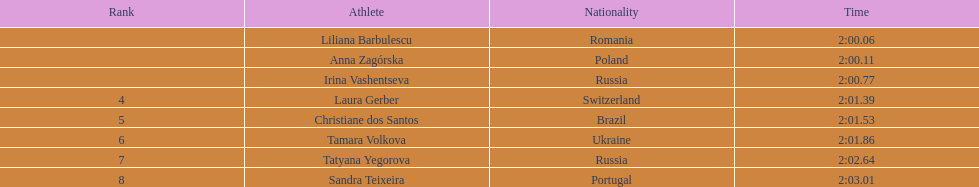Who were all of the athletes? Liliana Barbulescu, Anna Zagórska, Irina Vashentseva, Laura Gerber, Christiane dos Santos, Tamara Volkova, Tatyana Yegorova, Sandra Teixeira. What were their finishing times? 2:00.06, 2:00.11, 2:00.77, 2:01.39, 2:01.53, 2:01.86, 2:02.64, 2:03.01. Which athlete finished earliest? Liliana Barbulescu. 